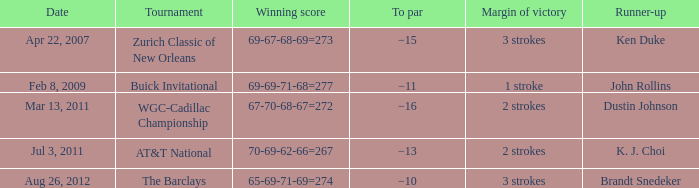On what date does a tournament have a 2-stroke victory margin and a par of -16? Mar 13, 2011. 